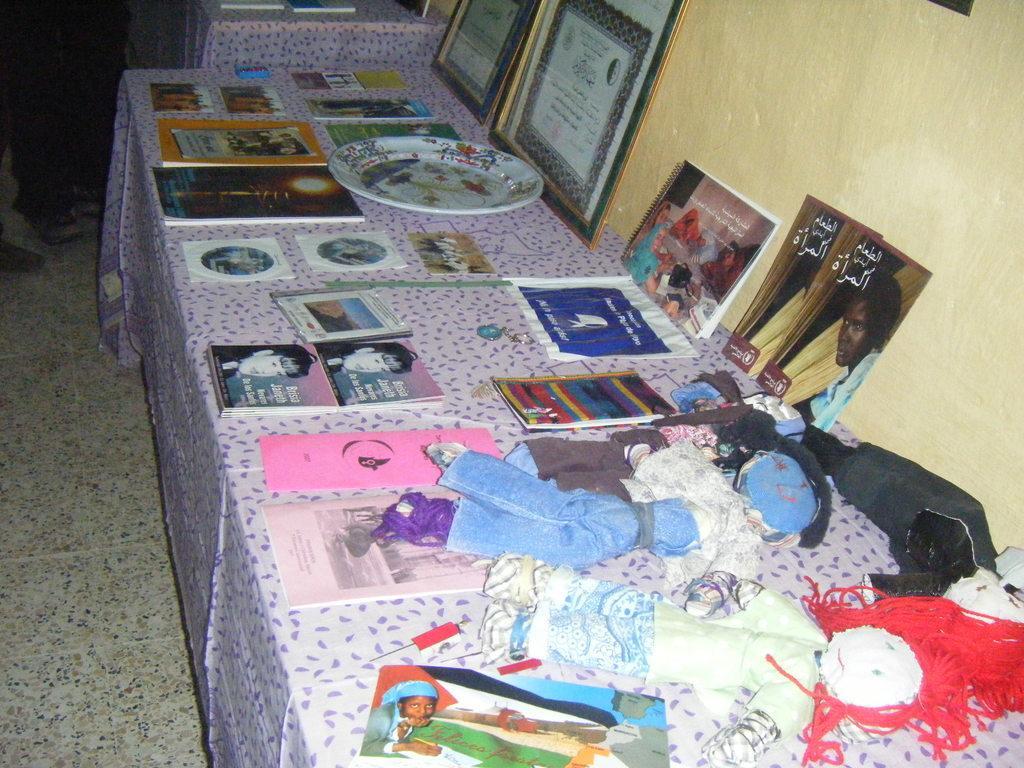In one or two sentences, can you explain what this image depicts? In this image we can see a platform with cloth. On that there are toys, books, plate, photo frames and many other things. On the right side there is a wall. 